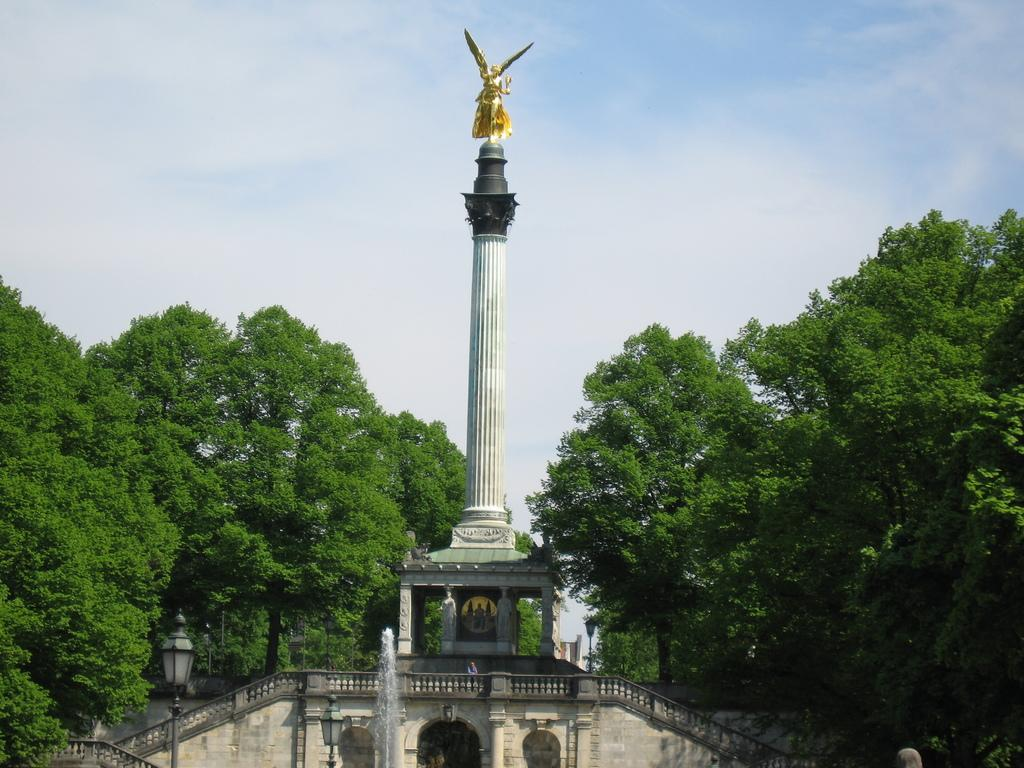What is the main subject of the picture? The main subject of the picture is a memorial. Are there any other objects or structures in the picture? Yes, there is a pole light in the picture. What type of natural elements can be seen in the picture? There are trees in the picture. How would you describe the weather in the picture? The sky is cloudy in the picture, suggesting a potentially overcast or cloudy day. What type of crate can be seen being used for play in the picture? There is no crate or any play-related activity depicted in the image. 